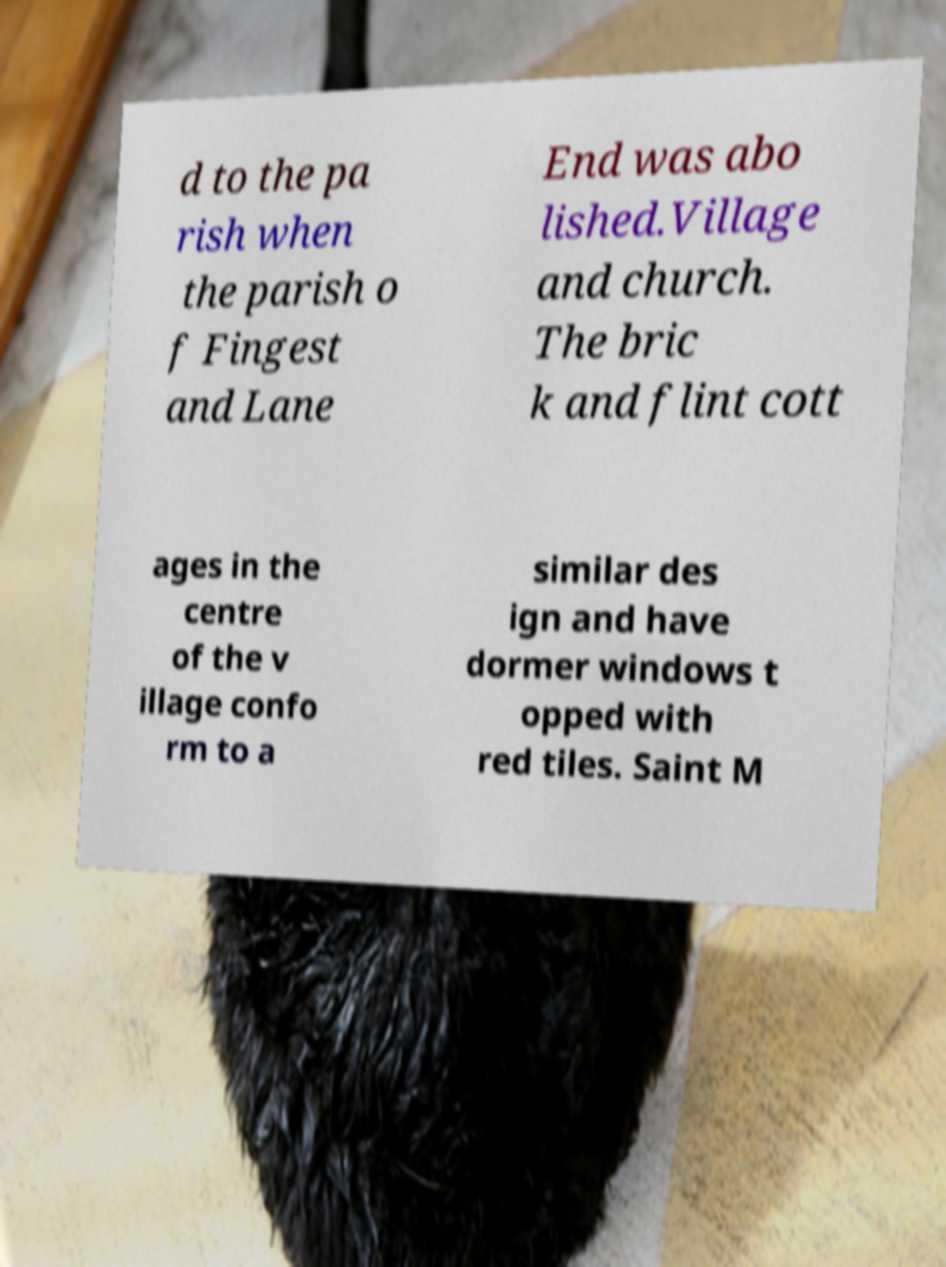For documentation purposes, I need the text within this image transcribed. Could you provide that? d to the pa rish when the parish o f Fingest and Lane End was abo lished.Village and church. The bric k and flint cott ages in the centre of the v illage confo rm to a similar des ign and have dormer windows t opped with red tiles. Saint M 